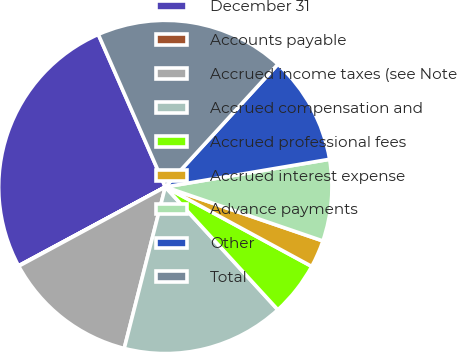Convert chart. <chart><loc_0><loc_0><loc_500><loc_500><pie_chart><fcel>December 31<fcel>Accounts payable<fcel>Accrued income taxes (see Note<fcel>Accrued compensation and<fcel>Accrued professional fees<fcel>Accrued interest expense<fcel>Advance payments<fcel>Other<fcel>Total<nl><fcel>26.26%<fcel>0.04%<fcel>13.15%<fcel>15.77%<fcel>5.28%<fcel>2.66%<fcel>7.91%<fcel>10.53%<fcel>18.4%<nl></chart> 